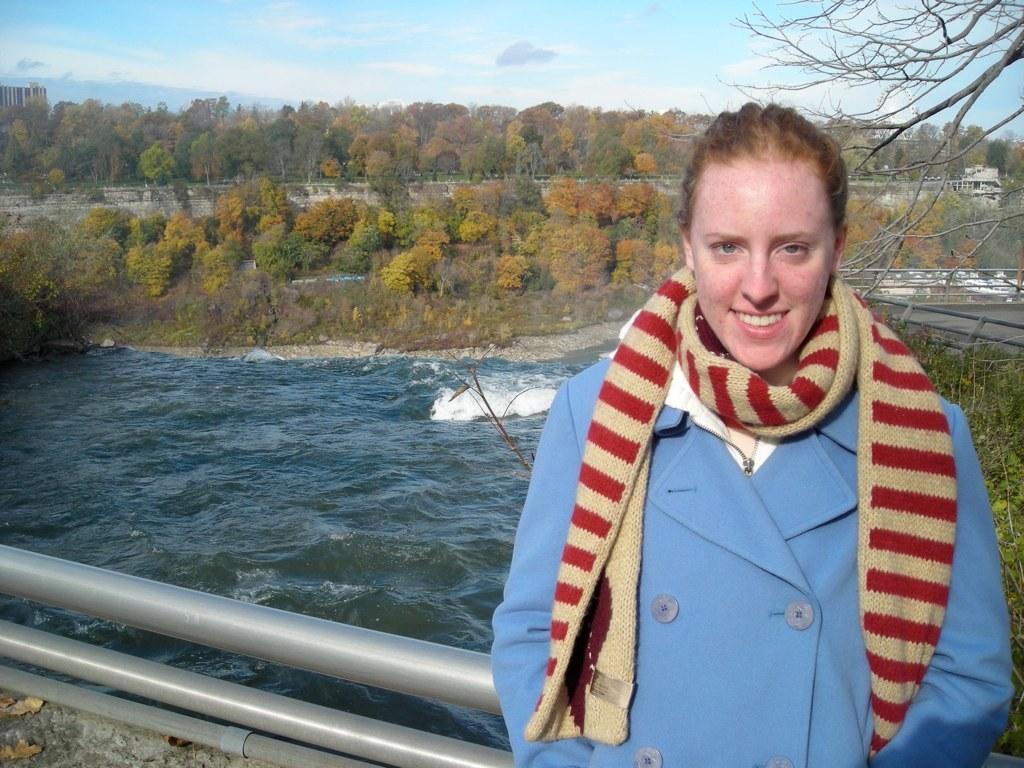Please provide a concise description of this image. In this image I can see the person wearing the dress which is in blue, white, red and brown color. In the background I can see the railing, water and many trees. I can also see the buildings, clouds and the sky. 